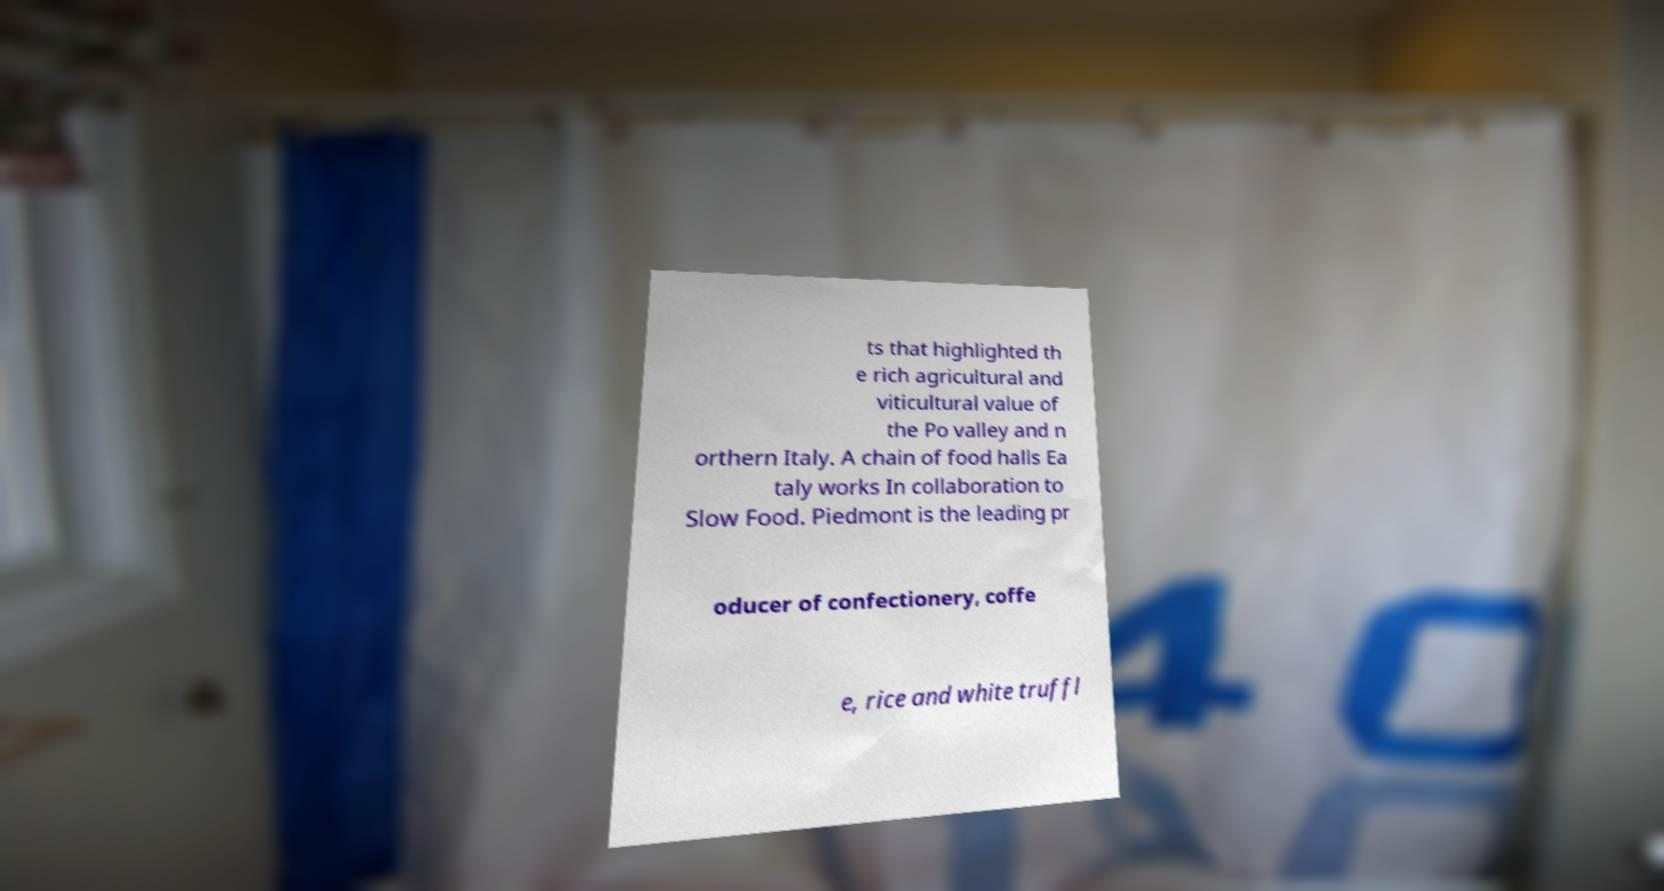Please read and relay the text visible in this image. What does it say? ts that highlighted th e rich agricultural and viticultural value of the Po valley and n orthern Italy. A chain of food halls Ea taly works In collaboration to Slow Food. Piedmont is the leading pr oducer of confectionery, coffe e, rice and white truffl 